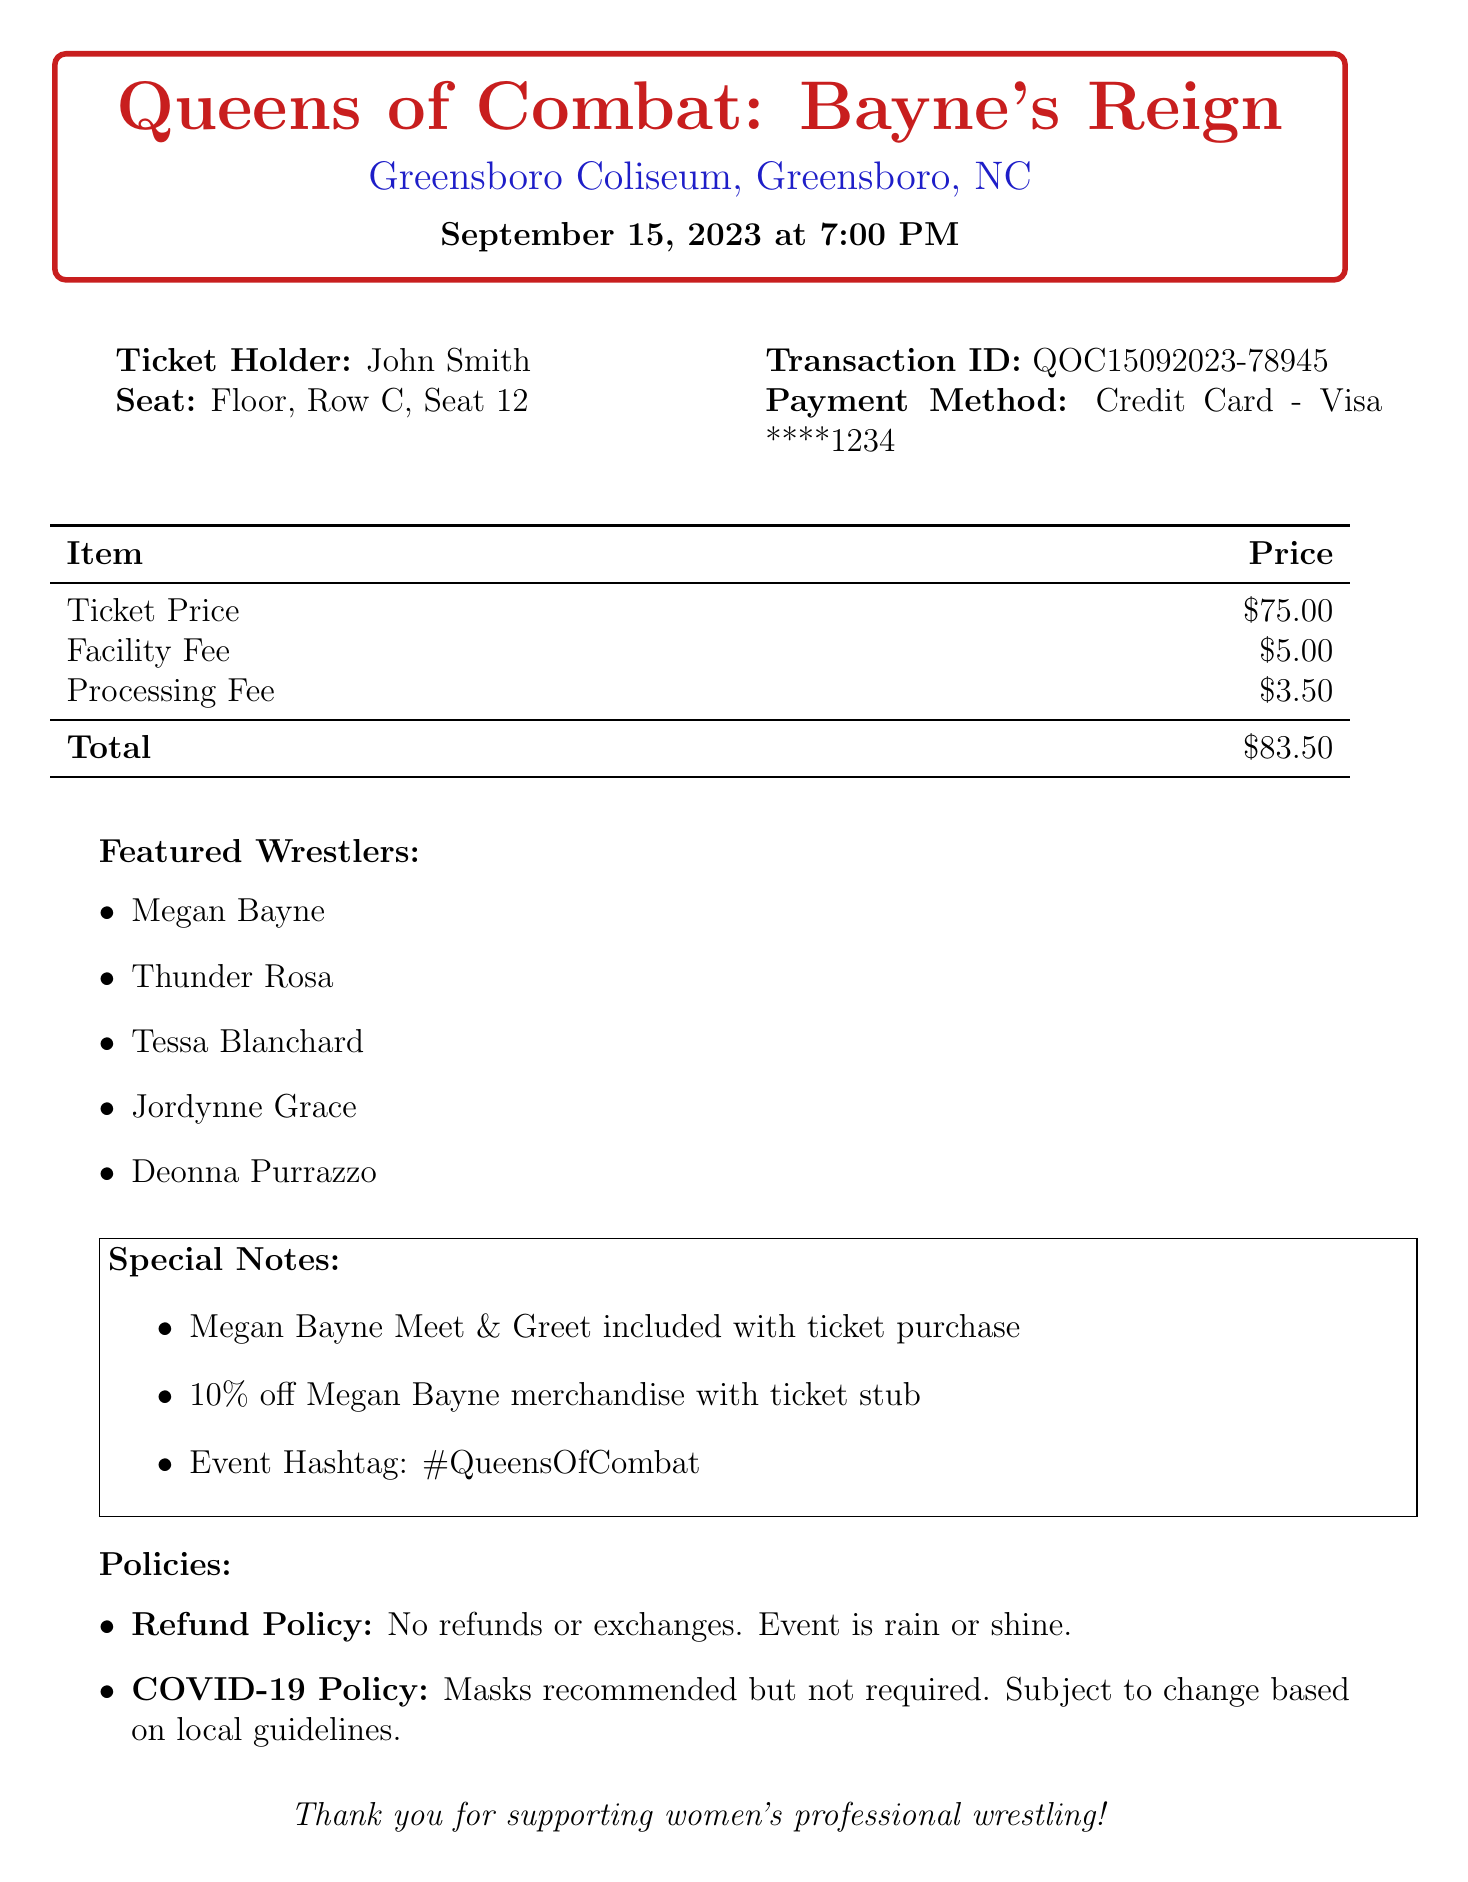What is the event name? The event name is clearly stated at the top of the document.
Answer: Queens of Combat: Bayne's Reign What is the ticket price? The ticket price appears in the pricing table in the document.
Answer: $75.00 Who is the ticket holder? The ticket holder's name is specified in the header section of the receipt.
Answer: John Smith What section is the seat located in? The seat location is detailed in the seat info section of the document.
Answer: Floor What is the total price paid for the ticket? The total price is calculated and displayed in the pricing table.
Answer: $83.50 Which wrestler's merchandise has a discount offer? The special notes section mentions the merchandise discount linked with the ticket stub.
Answer: Megan Bayne What are the possible actions regarding refunds? The refund policy section outlines the options available regarding refunds or exchanges.
Answer: No refunds or exchanges How many featured wrestlers are listed? The document contains a list of featured wrestlers that can be counted.
Answer: 5 What payment method was used for the ticket purchase? The payment method is clearly stated in the ticket info section.
Answer: Credit Card - Visa ****1234 